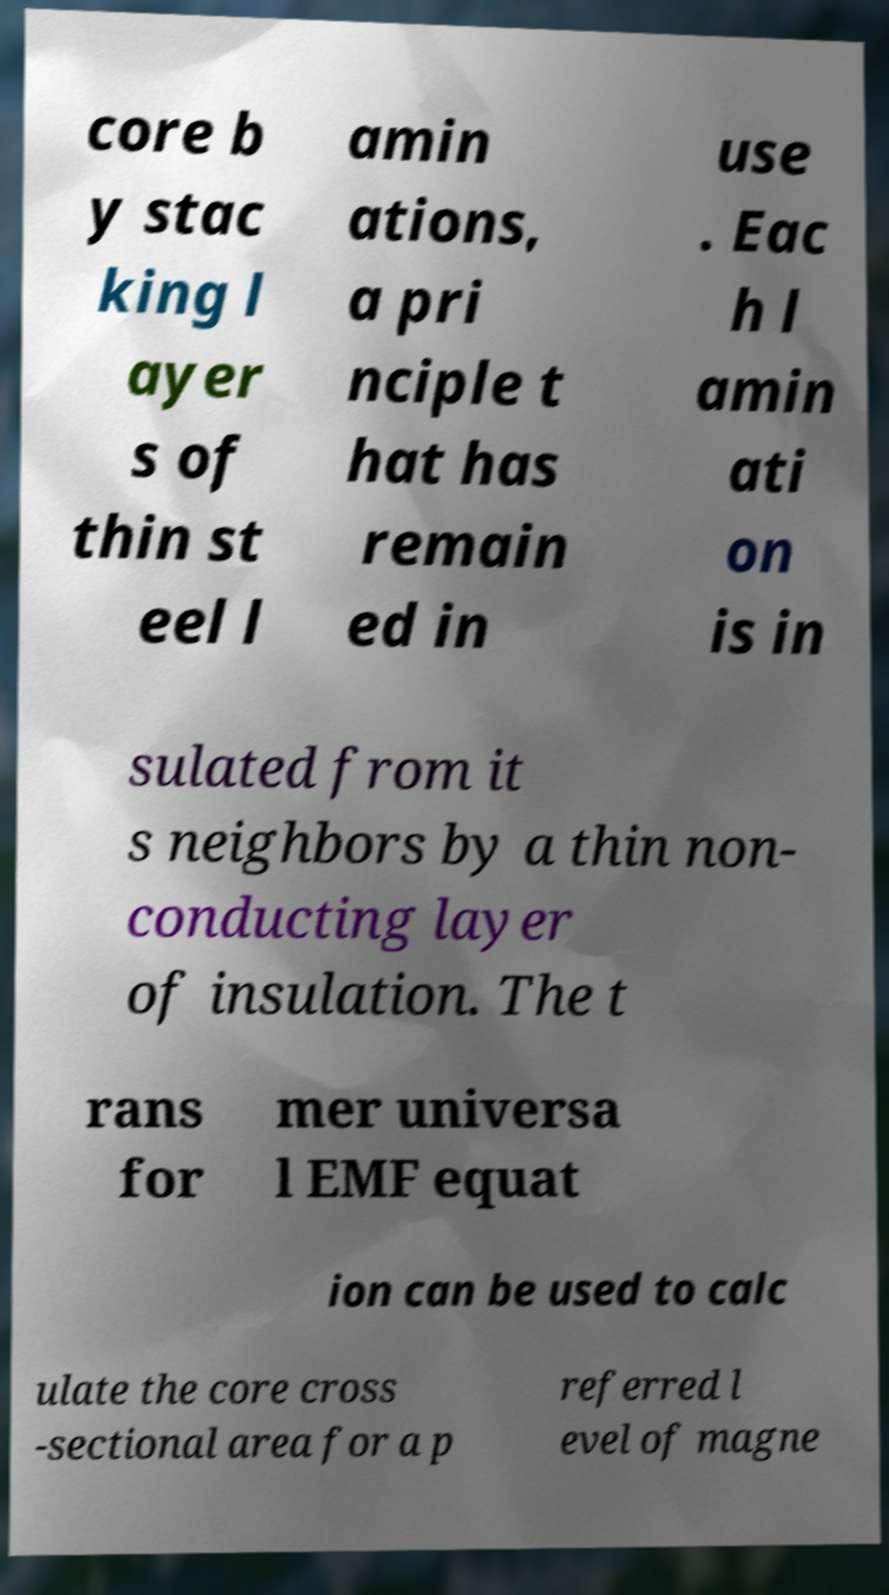Can you read and provide the text displayed in the image?This photo seems to have some interesting text. Can you extract and type it out for me? core b y stac king l ayer s of thin st eel l amin ations, a pri nciple t hat has remain ed in use . Eac h l amin ati on is in sulated from it s neighbors by a thin non- conducting layer of insulation. The t rans for mer universa l EMF equat ion can be used to calc ulate the core cross -sectional area for a p referred l evel of magne 